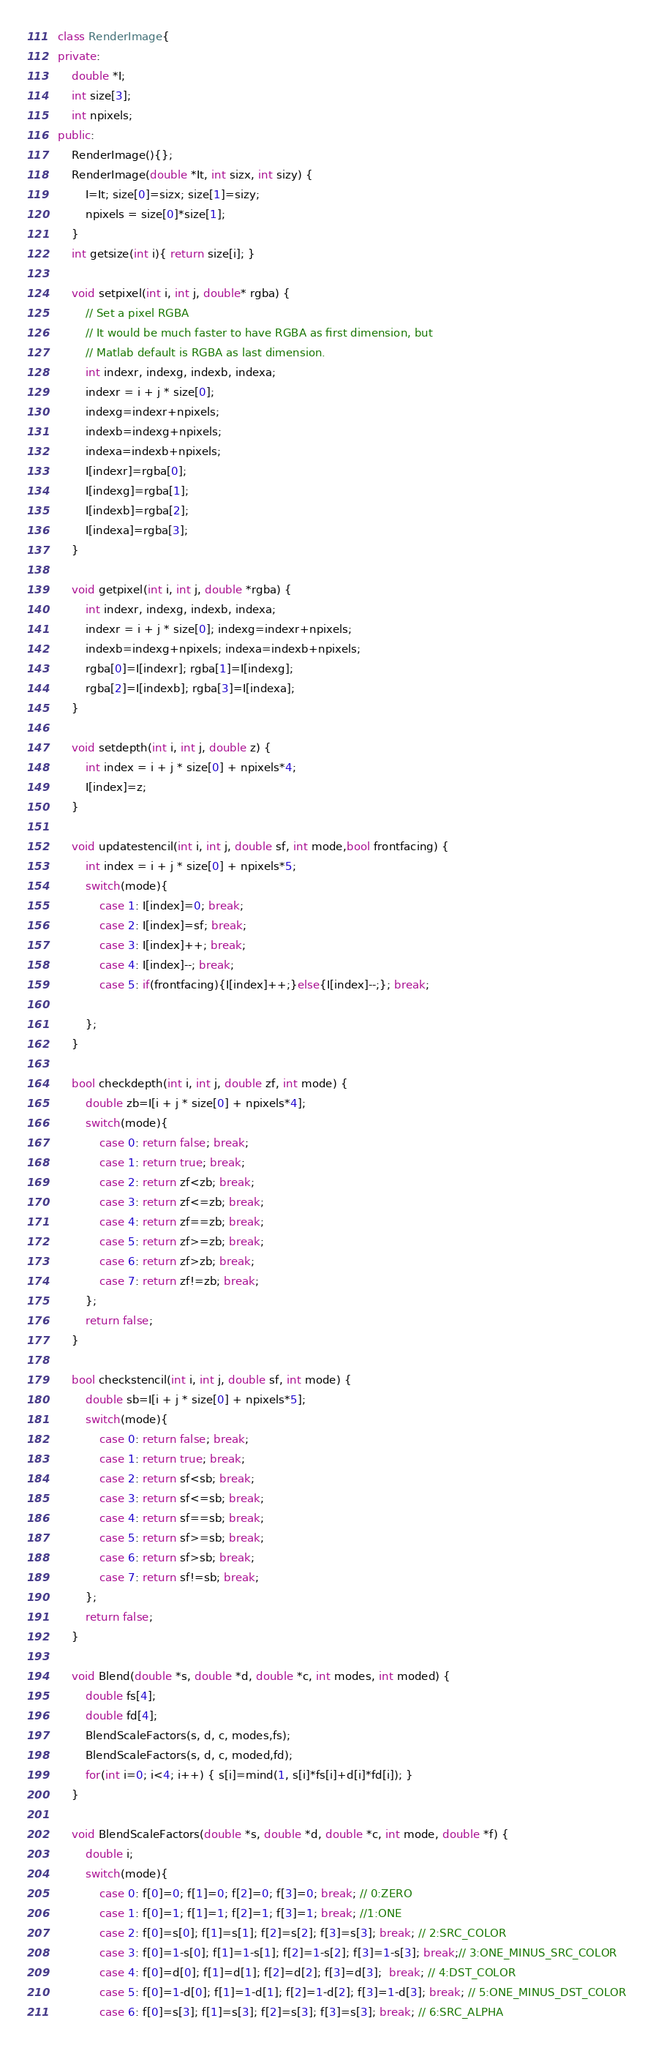<code> <loc_0><loc_0><loc_500><loc_500><_C++_>class RenderImage{
private:
    double *I;
    int size[3];
    int npixels;
public:
    RenderImage(){};
    RenderImage(double *It, int sizx, int sizy) {
        I=It; size[0]=sizx; size[1]=sizy;
        npixels = size[0]*size[1];
    }
    int getsize(int i){ return size[i]; }

    void setpixel(int i, int j, double* rgba) {
        // Set a pixel RGBA
        // It would be much faster to have RGBA as first dimension, but
        // Matlab default is RGBA as last dimension.
        int indexr, indexg, indexb, indexa;
        indexr = i + j * size[0];
        indexg=indexr+npixels;
        indexb=indexg+npixels;
        indexa=indexb+npixels;
        I[indexr]=rgba[0];
        I[indexg]=rgba[1];
        I[indexb]=rgba[2];
        I[indexa]=rgba[3];
    }

    void getpixel(int i, int j, double *rgba) {
        int indexr, indexg, indexb, indexa;
        indexr = i + j * size[0]; indexg=indexr+npixels;
        indexb=indexg+npixels; indexa=indexb+npixels;
        rgba[0]=I[indexr]; rgba[1]=I[indexg];
        rgba[2]=I[indexb]; rgba[3]=I[indexa];
    }

    void setdepth(int i, int j, double z) {
        int index = i + j * size[0] + npixels*4;
        I[index]=z;
    }

    void updatestencil(int i, int j, double sf, int mode,bool frontfacing) {
        int index = i + j * size[0] + npixels*5;
        switch(mode){
            case 1: I[index]=0; break;
            case 2: I[index]=sf; break;
            case 3: I[index]++; break;
            case 4: I[index]--; break;
            case 5: if(frontfacing){I[index]++;}else{I[index]--;}; break;

        };
    }

    bool checkdepth(int i, int j, double zf, int mode) {
        double zb=I[i + j * size[0] + npixels*4];
        switch(mode){
            case 0: return false; break;
            case 1: return true; break;
            case 2: return zf<zb; break;
            case 3: return zf<=zb; break;
            case 4: return zf==zb; break;
            case 5: return zf>=zb; break;
            case 6: return zf>zb; break;
            case 7: return zf!=zb; break;
        };
        return false;
    }

    bool checkstencil(int i, int j, double sf, int mode) {
        double sb=I[i + j * size[0] + npixels*5];
        switch(mode){
            case 0: return false; break;
            case 1: return true; break;
            case 2: return sf<sb; break;
            case 3: return sf<=sb; break;
            case 4: return sf==sb; break;
            case 5: return sf>=sb; break;
            case 6: return sf>sb; break;
            case 7: return sf!=sb; break;
        };
        return false;
    }

    void Blend(double *s, double *d, double *c, int modes, int moded) {
        double fs[4];
        double fd[4];
        BlendScaleFactors(s, d, c, modes,fs);
        BlendScaleFactors(s, d, c, moded,fd);
        for(int i=0; i<4; i++) { s[i]=mind(1, s[i]*fs[i]+d[i]*fd[i]); }
    }

    void BlendScaleFactors(double *s, double *d, double *c, int mode, double *f) {
        double i;
        switch(mode){
            case 0: f[0]=0; f[1]=0; f[2]=0; f[3]=0; break; // 0:ZERO
            case 1: f[0]=1; f[1]=1; f[2]=1; f[3]=1; break; //1:ONE
            case 2: f[0]=s[0]; f[1]=s[1]; f[2]=s[2]; f[3]=s[3]; break; // 2:SRC_COLOR
            case 3: f[0]=1-s[0]; f[1]=1-s[1]; f[2]=1-s[2]; f[3]=1-s[3]; break;// 3:ONE_MINUS_SRC_COLOR
            case 4: f[0]=d[0]; f[1]=d[1]; f[2]=d[2]; f[3]=d[3];  break; // 4:DST_COLOR
            case 5: f[0]=1-d[0]; f[1]=1-d[1]; f[2]=1-d[2]; f[3]=1-d[3]; break; // 5:ONE_MINUS_DST_COLOR
            case 6: f[0]=s[3]; f[1]=s[3]; f[2]=s[3]; f[3]=s[3]; break; // 6:SRC_ALPHA</code> 